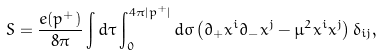Convert formula to latex. <formula><loc_0><loc_0><loc_500><loc_500>S = \frac { e ( p ^ { + } ) } { 8 \pi } \int d \tau \int _ { 0 } ^ { 4 \pi | p ^ { + } | } d \sigma \left ( \partial _ { + } x ^ { i } \partial _ { - } x ^ { j } - \mu ^ { 2 } x ^ { i } x ^ { j } \right ) \delta _ { i j } ,</formula> 